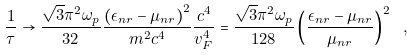<formula> <loc_0><loc_0><loc_500><loc_500>\frac { 1 } { \tau } \rightarrow \frac { \sqrt { 3 } \pi ^ { 2 } \omega _ { p } } { 3 2 } \frac { \left ( \epsilon _ { n r } - \mu _ { n r } \right ) ^ { 2 } } { m ^ { 2 } c ^ { 4 } } \frac { c ^ { 4 } } { v _ { F } ^ { 4 } } = \frac { \sqrt { 3 } \pi ^ { 2 } \omega _ { p } } { 1 2 8 } \left ( \frac { \epsilon _ { n r } - \mu _ { n r } } { \mu _ { n r } } \right ) ^ { 2 } \ ,</formula> 